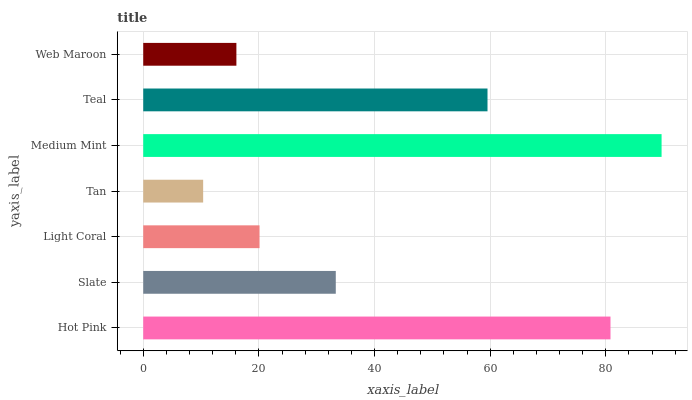Is Tan the minimum?
Answer yes or no. Yes. Is Medium Mint the maximum?
Answer yes or no. Yes. Is Slate the minimum?
Answer yes or no. No. Is Slate the maximum?
Answer yes or no. No. Is Hot Pink greater than Slate?
Answer yes or no. Yes. Is Slate less than Hot Pink?
Answer yes or no. Yes. Is Slate greater than Hot Pink?
Answer yes or no. No. Is Hot Pink less than Slate?
Answer yes or no. No. Is Slate the high median?
Answer yes or no. Yes. Is Slate the low median?
Answer yes or no. Yes. Is Light Coral the high median?
Answer yes or no. No. Is Tan the low median?
Answer yes or no. No. 